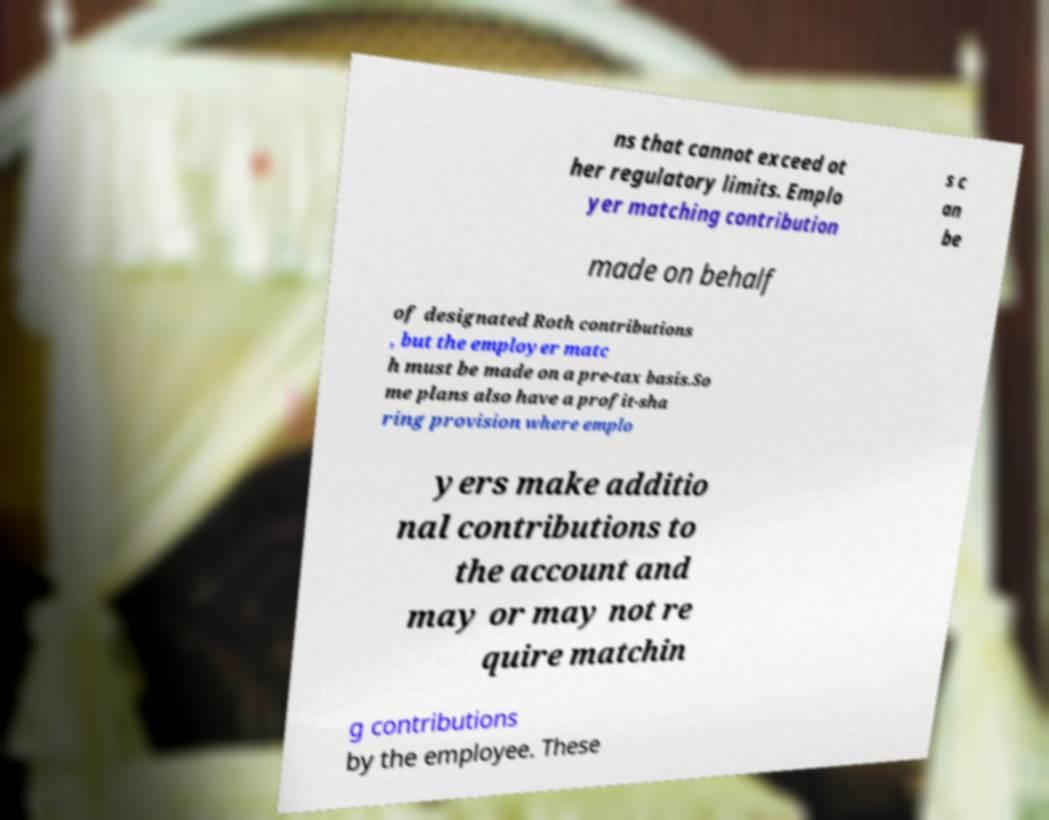What messages or text are displayed in this image? I need them in a readable, typed format. ns that cannot exceed ot her regulatory limits. Emplo yer matching contribution s c an be made on behalf of designated Roth contributions , but the employer matc h must be made on a pre-tax basis.So me plans also have a profit-sha ring provision where emplo yers make additio nal contributions to the account and may or may not re quire matchin g contributions by the employee. These 